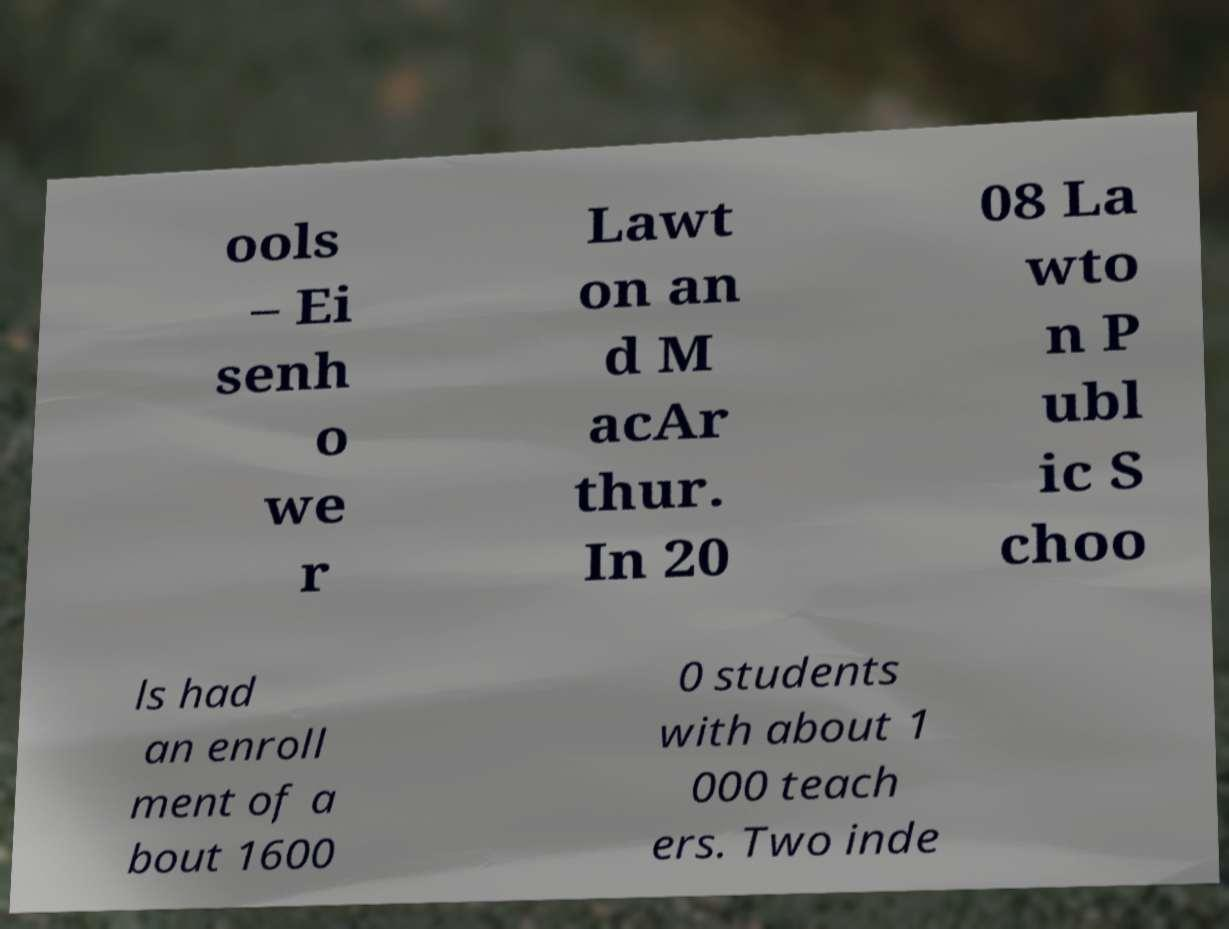There's text embedded in this image that I need extracted. Can you transcribe it verbatim? ools – Ei senh o we r Lawt on an d M acAr thur. In 20 08 La wto n P ubl ic S choo ls had an enroll ment of a bout 1600 0 students with about 1 000 teach ers. Two inde 